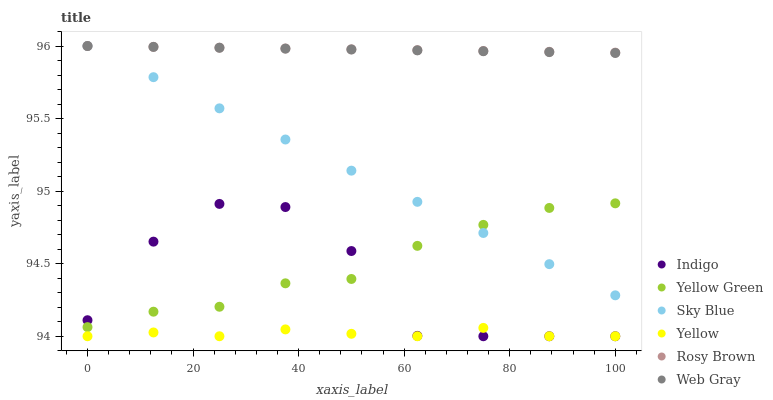Does Yellow have the minimum area under the curve?
Answer yes or no. Yes. Does Rosy Brown have the maximum area under the curve?
Answer yes or no. Yes. Does Indigo have the minimum area under the curve?
Answer yes or no. No. Does Indigo have the maximum area under the curve?
Answer yes or no. No. Is Rosy Brown the smoothest?
Answer yes or no. Yes. Is Indigo the roughest?
Answer yes or no. Yes. Is Yellow Green the smoothest?
Answer yes or no. No. Is Yellow Green the roughest?
Answer yes or no. No. Does Indigo have the lowest value?
Answer yes or no. Yes. Does Yellow Green have the lowest value?
Answer yes or no. No. Does Sky Blue have the highest value?
Answer yes or no. Yes. Does Indigo have the highest value?
Answer yes or no. No. Is Yellow less than Web Gray?
Answer yes or no. Yes. Is Yellow Green greater than Yellow?
Answer yes or no. Yes. Does Web Gray intersect Rosy Brown?
Answer yes or no. Yes. Is Web Gray less than Rosy Brown?
Answer yes or no. No. Is Web Gray greater than Rosy Brown?
Answer yes or no. No. Does Yellow intersect Web Gray?
Answer yes or no. No. 